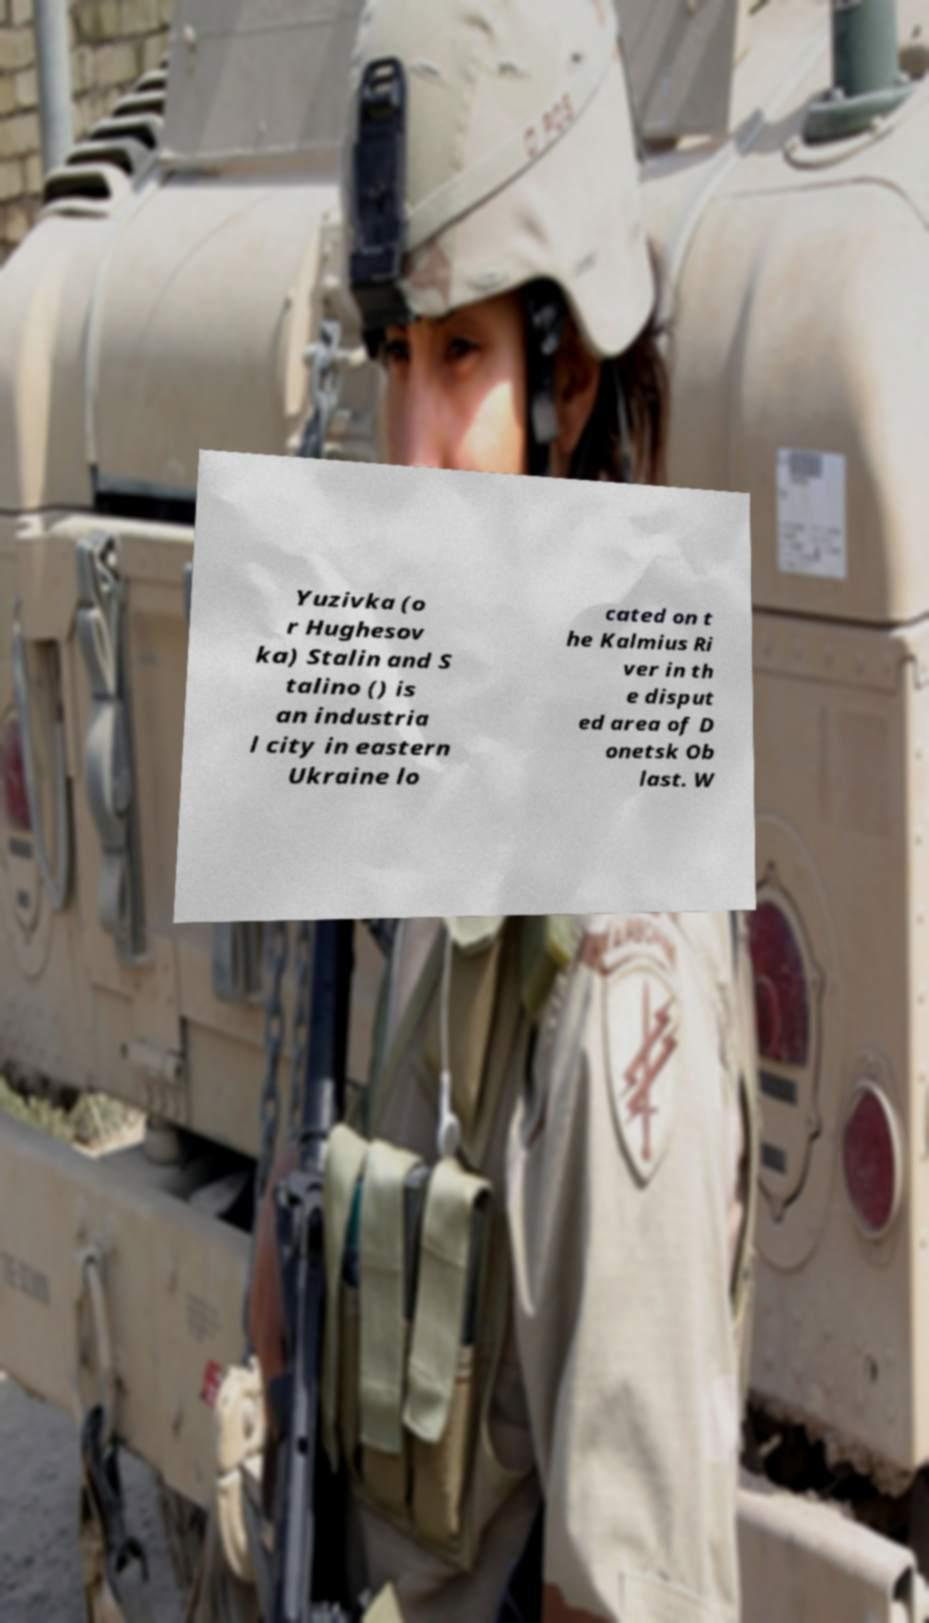Can you accurately transcribe the text from the provided image for me? Yuzivka (o r Hughesov ka) Stalin and S talino () is an industria l city in eastern Ukraine lo cated on t he Kalmius Ri ver in th e disput ed area of D onetsk Ob last. W 